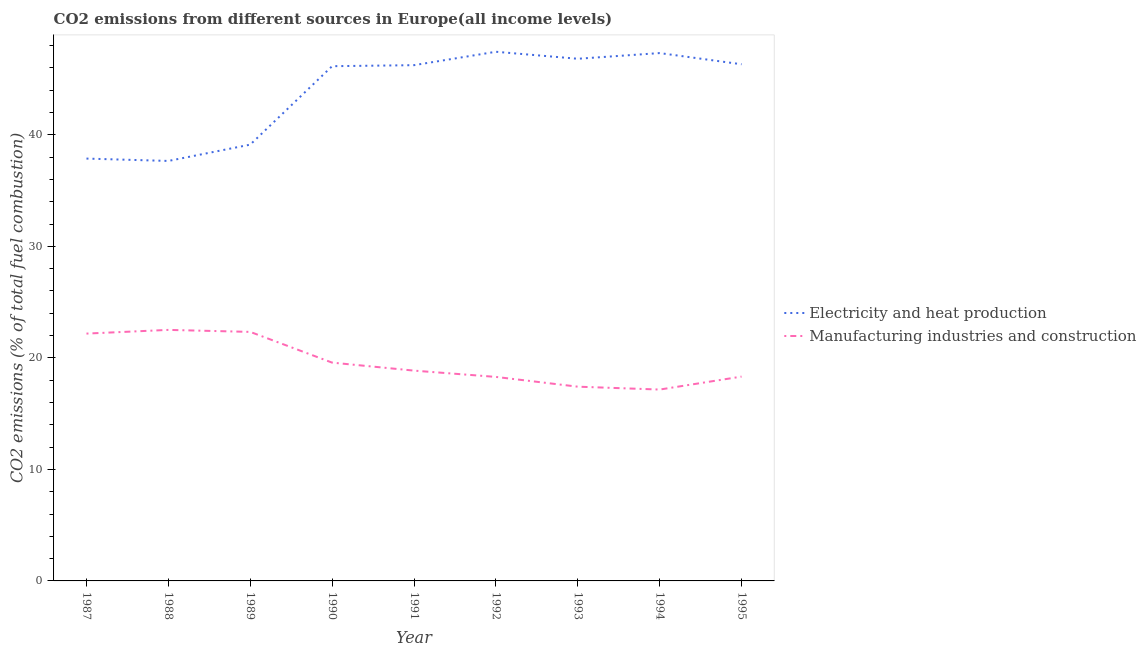How many different coloured lines are there?
Provide a short and direct response. 2. Does the line corresponding to co2 emissions due to electricity and heat production intersect with the line corresponding to co2 emissions due to manufacturing industries?
Your response must be concise. No. What is the co2 emissions due to electricity and heat production in 1992?
Your answer should be compact. 47.45. Across all years, what is the maximum co2 emissions due to manufacturing industries?
Offer a terse response. 22.51. Across all years, what is the minimum co2 emissions due to manufacturing industries?
Your response must be concise. 17.16. In which year was the co2 emissions due to manufacturing industries maximum?
Make the answer very short. 1988. What is the total co2 emissions due to electricity and heat production in the graph?
Provide a succinct answer. 394.98. What is the difference between the co2 emissions due to electricity and heat production in 1990 and that in 1994?
Your answer should be very brief. -1.18. What is the difference between the co2 emissions due to electricity and heat production in 1989 and the co2 emissions due to manufacturing industries in 1990?
Provide a succinct answer. 19.55. What is the average co2 emissions due to manufacturing industries per year?
Ensure brevity in your answer.  19.63. In the year 1992, what is the difference between the co2 emissions due to electricity and heat production and co2 emissions due to manufacturing industries?
Your answer should be compact. 29.15. What is the ratio of the co2 emissions due to manufacturing industries in 1988 to that in 1991?
Offer a terse response. 1.19. Is the co2 emissions due to electricity and heat production in 1988 less than that in 1995?
Your answer should be very brief. Yes. What is the difference between the highest and the second highest co2 emissions due to electricity and heat production?
Ensure brevity in your answer.  0.12. What is the difference between the highest and the lowest co2 emissions due to manufacturing industries?
Offer a very short reply. 5.35. In how many years, is the co2 emissions due to manufacturing industries greater than the average co2 emissions due to manufacturing industries taken over all years?
Offer a very short reply. 3. Is the sum of the co2 emissions due to manufacturing industries in 1988 and 1993 greater than the maximum co2 emissions due to electricity and heat production across all years?
Give a very brief answer. No. Is the co2 emissions due to manufacturing industries strictly less than the co2 emissions due to electricity and heat production over the years?
Offer a terse response. Yes. How many years are there in the graph?
Keep it short and to the point. 9. Are the values on the major ticks of Y-axis written in scientific E-notation?
Your answer should be compact. No. Does the graph contain any zero values?
Offer a very short reply. No. Does the graph contain grids?
Keep it short and to the point. No. Where does the legend appear in the graph?
Make the answer very short. Center right. How many legend labels are there?
Your response must be concise. 2. How are the legend labels stacked?
Make the answer very short. Vertical. What is the title of the graph?
Provide a succinct answer. CO2 emissions from different sources in Europe(all income levels). Does "Private funds" appear as one of the legend labels in the graph?
Make the answer very short. No. What is the label or title of the X-axis?
Ensure brevity in your answer.  Year. What is the label or title of the Y-axis?
Provide a succinct answer. CO2 emissions (% of total fuel combustion). What is the CO2 emissions (% of total fuel combustion) in Electricity and heat production in 1987?
Your answer should be compact. 37.87. What is the CO2 emissions (% of total fuel combustion) of Manufacturing industries and construction in 1987?
Give a very brief answer. 22.18. What is the CO2 emissions (% of total fuel combustion) in Electricity and heat production in 1988?
Give a very brief answer. 37.66. What is the CO2 emissions (% of total fuel combustion) in Manufacturing industries and construction in 1988?
Make the answer very short. 22.51. What is the CO2 emissions (% of total fuel combustion) of Electricity and heat production in 1989?
Provide a short and direct response. 39.12. What is the CO2 emissions (% of total fuel combustion) in Manufacturing industries and construction in 1989?
Offer a terse response. 22.33. What is the CO2 emissions (% of total fuel combustion) of Electricity and heat production in 1990?
Your answer should be very brief. 46.16. What is the CO2 emissions (% of total fuel combustion) of Manufacturing industries and construction in 1990?
Your response must be concise. 19.57. What is the CO2 emissions (% of total fuel combustion) in Electricity and heat production in 1991?
Your answer should be compact. 46.25. What is the CO2 emissions (% of total fuel combustion) in Manufacturing industries and construction in 1991?
Your response must be concise. 18.86. What is the CO2 emissions (% of total fuel combustion) in Electricity and heat production in 1992?
Give a very brief answer. 47.45. What is the CO2 emissions (% of total fuel combustion) in Manufacturing industries and construction in 1992?
Your answer should be compact. 18.29. What is the CO2 emissions (% of total fuel combustion) in Electricity and heat production in 1993?
Make the answer very short. 46.82. What is the CO2 emissions (% of total fuel combustion) in Manufacturing industries and construction in 1993?
Provide a short and direct response. 17.42. What is the CO2 emissions (% of total fuel combustion) in Electricity and heat production in 1994?
Your answer should be compact. 47.33. What is the CO2 emissions (% of total fuel combustion) in Manufacturing industries and construction in 1994?
Give a very brief answer. 17.16. What is the CO2 emissions (% of total fuel combustion) in Electricity and heat production in 1995?
Provide a succinct answer. 46.33. What is the CO2 emissions (% of total fuel combustion) in Manufacturing industries and construction in 1995?
Ensure brevity in your answer.  18.32. Across all years, what is the maximum CO2 emissions (% of total fuel combustion) in Electricity and heat production?
Your answer should be very brief. 47.45. Across all years, what is the maximum CO2 emissions (% of total fuel combustion) in Manufacturing industries and construction?
Your response must be concise. 22.51. Across all years, what is the minimum CO2 emissions (% of total fuel combustion) of Electricity and heat production?
Give a very brief answer. 37.66. Across all years, what is the minimum CO2 emissions (% of total fuel combustion) in Manufacturing industries and construction?
Your answer should be compact. 17.16. What is the total CO2 emissions (% of total fuel combustion) in Electricity and heat production in the graph?
Provide a short and direct response. 394.98. What is the total CO2 emissions (% of total fuel combustion) of Manufacturing industries and construction in the graph?
Your answer should be compact. 176.64. What is the difference between the CO2 emissions (% of total fuel combustion) of Electricity and heat production in 1987 and that in 1988?
Provide a short and direct response. 0.21. What is the difference between the CO2 emissions (% of total fuel combustion) in Manufacturing industries and construction in 1987 and that in 1988?
Offer a very short reply. -0.33. What is the difference between the CO2 emissions (% of total fuel combustion) of Electricity and heat production in 1987 and that in 1989?
Your response must be concise. -1.25. What is the difference between the CO2 emissions (% of total fuel combustion) in Manufacturing industries and construction in 1987 and that in 1989?
Offer a very short reply. -0.15. What is the difference between the CO2 emissions (% of total fuel combustion) in Electricity and heat production in 1987 and that in 1990?
Keep it short and to the point. -8.28. What is the difference between the CO2 emissions (% of total fuel combustion) in Manufacturing industries and construction in 1987 and that in 1990?
Ensure brevity in your answer.  2.6. What is the difference between the CO2 emissions (% of total fuel combustion) in Electricity and heat production in 1987 and that in 1991?
Offer a terse response. -8.38. What is the difference between the CO2 emissions (% of total fuel combustion) in Manufacturing industries and construction in 1987 and that in 1991?
Your answer should be very brief. 3.32. What is the difference between the CO2 emissions (% of total fuel combustion) in Electricity and heat production in 1987 and that in 1992?
Offer a terse response. -9.58. What is the difference between the CO2 emissions (% of total fuel combustion) in Manufacturing industries and construction in 1987 and that in 1992?
Make the answer very short. 3.88. What is the difference between the CO2 emissions (% of total fuel combustion) of Electricity and heat production in 1987 and that in 1993?
Your answer should be very brief. -8.95. What is the difference between the CO2 emissions (% of total fuel combustion) in Manufacturing industries and construction in 1987 and that in 1993?
Your answer should be compact. 4.76. What is the difference between the CO2 emissions (% of total fuel combustion) in Electricity and heat production in 1987 and that in 1994?
Your answer should be very brief. -9.46. What is the difference between the CO2 emissions (% of total fuel combustion) in Manufacturing industries and construction in 1987 and that in 1994?
Your response must be concise. 5.02. What is the difference between the CO2 emissions (% of total fuel combustion) in Electricity and heat production in 1987 and that in 1995?
Make the answer very short. -8.46. What is the difference between the CO2 emissions (% of total fuel combustion) in Manufacturing industries and construction in 1987 and that in 1995?
Provide a succinct answer. 3.86. What is the difference between the CO2 emissions (% of total fuel combustion) in Electricity and heat production in 1988 and that in 1989?
Offer a terse response. -1.46. What is the difference between the CO2 emissions (% of total fuel combustion) in Manufacturing industries and construction in 1988 and that in 1989?
Make the answer very short. 0.18. What is the difference between the CO2 emissions (% of total fuel combustion) of Electricity and heat production in 1988 and that in 1990?
Your response must be concise. -8.5. What is the difference between the CO2 emissions (% of total fuel combustion) in Manufacturing industries and construction in 1988 and that in 1990?
Provide a short and direct response. 2.93. What is the difference between the CO2 emissions (% of total fuel combustion) of Electricity and heat production in 1988 and that in 1991?
Your answer should be very brief. -8.59. What is the difference between the CO2 emissions (% of total fuel combustion) in Manufacturing industries and construction in 1988 and that in 1991?
Give a very brief answer. 3.65. What is the difference between the CO2 emissions (% of total fuel combustion) of Electricity and heat production in 1988 and that in 1992?
Make the answer very short. -9.79. What is the difference between the CO2 emissions (% of total fuel combustion) in Manufacturing industries and construction in 1988 and that in 1992?
Provide a short and direct response. 4.22. What is the difference between the CO2 emissions (% of total fuel combustion) of Electricity and heat production in 1988 and that in 1993?
Provide a succinct answer. -9.16. What is the difference between the CO2 emissions (% of total fuel combustion) of Manufacturing industries and construction in 1988 and that in 1993?
Provide a short and direct response. 5.09. What is the difference between the CO2 emissions (% of total fuel combustion) of Electricity and heat production in 1988 and that in 1994?
Make the answer very short. -9.67. What is the difference between the CO2 emissions (% of total fuel combustion) in Manufacturing industries and construction in 1988 and that in 1994?
Your response must be concise. 5.35. What is the difference between the CO2 emissions (% of total fuel combustion) of Electricity and heat production in 1988 and that in 1995?
Ensure brevity in your answer.  -8.67. What is the difference between the CO2 emissions (% of total fuel combustion) in Manufacturing industries and construction in 1988 and that in 1995?
Your answer should be compact. 4.19. What is the difference between the CO2 emissions (% of total fuel combustion) in Electricity and heat production in 1989 and that in 1990?
Give a very brief answer. -7.03. What is the difference between the CO2 emissions (% of total fuel combustion) of Manufacturing industries and construction in 1989 and that in 1990?
Your answer should be very brief. 2.76. What is the difference between the CO2 emissions (% of total fuel combustion) of Electricity and heat production in 1989 and that in 1991?
Your response must be concise. -7.13. What is the difference between the CO2 emissions (% of total fuel combustion) of Manufacturing industries and construction in 1989 and that in 1991?
Make the answer very short. 3.47. What is the difference between the CO2 emissions (% of total fuel combustion) of Electricity and heat production in 1989 and that in 1992?
Give a very brief answer. -8.33. What is the difference between the CO2 emissions (% of total fuel combustion) in Manufacturing industries and construction in 1989 and that in 1992?
Give a very brief answer. 4.04. What is the difference between the CO2 emissions (% of total fuel combustion) of Electricity and heat production in 1989 and that in 1993?
Ensure brevity in your answer.  -7.7. What is the difference between the CO2 emissions (% of total fuel combustion) of Manufacturing industries and construction in 1989 and that in 1993?
Ensure brevity in your answer.  4.91. What is the difference between the CO2 emissions (% of total fuel combustion) in Electricity and heat production in 1989 and that in 1994?
Your answer should be very brief. -8.21. What is the difference between the CO2 emissions (% of total fuel combustion) in Manufacturing industries and construction in 1989 and that in 1994?
Your response must be concise. 5.17. What is the difference between the CO2 emissions (% of total fuel combustion) in Electricity and heat production in 1989 and that in 1995?
Give a very brief answer. -7.21. What is the difference between the CO2 emissions (% of total fuel combustion) in Manufacturing industries and construction in 1989 and that in 1995?
Your answer should be compact. 4.01. What is the difference between the CO2 emissions (% of total fuel combustion) in Electricity and heat production in 1990 and that in 1991?
Keep it short and to the point. -0.09. What is the difference between the CO2 emissions (% of total fuel combustion) of Manufacturing industries and construction in 1990 and that in 1991?
Offer a terse response. 0.72. What is the difference between the CO2 emissions (% of total fuel combustion) in Electricity and heat production in 1990 and that in 1992?
Provide a succinct answer. -1.29. What is the difference between the CO2 emissions (% of total fuel combustion) of Manufacturing industries and construction in 1990 and that in 1992?
Keep it short and to the point. 1.28. What is the difference between the CO2 emissions (% of total fuel combustion) of Electricity and heat production in 1990 and that in 1993?
Keep it short and to the point. -0.67. What is the difference between the CO2 emissions (% of total fuel combustion) in Manufacturing industries and construction in 1990 and that in 1993?
Keep it short and to the point. 2.16. What is the difference between the CO2 emissions (% of total fuel combustion) of Electricity and heat production in 1990 and that in 1994?
Your answer should be very brief. -1.18. What is the difference between the CO2 emissions (% of total fuel combustion) in Manufacturing industries and construction in 1990 and that in 1994?
Your response must be concise. 2.42. What is the difference between the CO2 emissions (% of total fuel combustion) of Electricity and heat production in 1990 and that in 1995?
Provide a succinct answer. -0.17. What is the difference between the CO2 emissions (% of total fuel combustion) of Manufacturing industries and construction in 1990 and that in 1995?
Give a very brief answer. 1.25. What is the difference between the CO2 emissions (% of total fuel combustion) in Electricity and heat production in 1991 and that in 1992?
Your answer should be very brief. -1.2. What is the difference between the CO2 emissions (% of total fuel combustion) of Manufacturing industries and construction in 1991 and that in 1992?
Provide a short and direct response. 0.56. What is the difference between the CO2 emissions (% of total fuel combustion) of Electricity and heat production in 1991 and that in 1993?
Keep it short and to the point. -0.57. What is the difference between the CO2 emissions (% of total fuel combustion) of Manufacturing industries and construction in 1991 and that in 1993?
Keep it short and to the point. 1.44. What is the difference between the CO2 emissions (% of total fuel combustion) in Electricity and heat production in 1991 and that in 1994?
Keep it short and to the point. -1.08. What is the difference between the CO2 emissions (% of total fuel combustion) in Manufacturing industries and construction in 1991 and that in 1994?
Your answer should be very brief. 1.7. What is the difference between the CO2 emissions (% of total fuel combustion) of Electricity and heat production in 1991 and that in 1995?
Keep it short and to the point. -0.08. What is the difference between the CO2 emissions (% of total fuel combustion) in Manufacturing industries and construction in 1991 and that in 1995?
Ensure brevity in your answer.  0.54. What is the difference between the CO2 emissions (% of total fuel combustion) in Electricity and heat production in 1992 and that in 1993?
Give a very brief answer. 0.63. What is the difference between the CO2 emissions (% of total fuel combustion) of Manufacturing industries and construction in 1992 and that in 1993?
Offer a terse response. 0.88. What is the difference between the CO2 emissions (% of total fuel combustion) of Electricity and heat production in 1992 and that in 1994?
Offer a terse response. 0.12. What is the difference between the CO2 emissions (% of total fuel combustion) in Manufacturing industries and construction in 1992 and that in 1994?
Your answer should be very brief. 1.13. What is the difference between the CO2 emissions (% of total fuel combustion) of Electricity and heat production in 1992 and that in 1995?
Offer a terse response. 1.12. What is the difference between the CO2 emissions (% of total fuel combustion) in Manufacturing industries and construction in 1992 and that in 1995?
Ensure brevity in your answer.  -0.03. What is the difference between the CO2 emissions (% of total fuel combustion) of Electricity and heat production in 1993 and that in 1994?
Ensure brevity in your answer.  -0.51. What is the difference between the CO2 emissions (% of total fuel combustion) in Manufacturing industries and construction in 1993 and that in 1994?
Keep it short and to the point. 0.26. What is the difference between the CO2 emissions (% of total fuel combustion) of Electricity and heat production in 1993 and that in 1995?
Your answer should be very brief. 0.49. What is the difference between the CO2 emissions (% of total fuel combustion) in Manufacturing industries and construction in 1993 and that in 1995?
Your answer should be compact. -0.9. What is the difference between the CO2 emissions (% of total fuel combustion) of Electricity and heat production in 1994 and that in 1995?
Ensure brevity in your answer.  1. What is the difference between the CO2 emissions (% of total fuel combustion) of Manufacturing industries and construction in 1994 and that in 1995?
Your answer should be very brief. -1.16. What is the difference between the CO2 emissions (% of total fuel combustion) in Electricity and heat production in 1987 and the CO2 emissions (% of total fuel combustion) in Manufacturing industries and construction in 1988?
Your answer should be very brief. 15.36. What is the difference between the CO2 emissions (% of total fuel combustion) of Electricity and heat production in 1987 and the CO2 emissions (% of total fuel combustion) of Manufacturing industries and construction in 1989?
Offer a terse response. 15.54. What is the difference between the CO2 emissions (% of total fuel combustion) in Electricity and heat production in 1987 and the CO2 emissions (% of total fuel combustion) in Manufacturing industries and construction in 1990?
Provide a short and direct response. 18.3. What is the difference between the CO2 emissions (% of total fuel combustion) in Electricity and heat production in 1987 and the CO2 emissions (% of total fuel combustion) in Manufacturing industries and construction in 1991?
Your response must be concise. 19.01. What is the difference between the CO2 emissions (% of total fuel combustion) in Electricity and heat production in 1987 and the CO2 emissions (% of total fuel combustion) in Manufacturing industries and construction in 1992?
Provide a short and direct response. 19.58. What is the difference between the CO2 emissions (% of total fuel combustion) of Electricity and heat production in 1987 and the CO2 emissions (% of total fuel combustion) of Manufacturing industries and construction in 1993?
Your response must be concise. 20.45. What is the difference between the CO2 emissions (% of total fuel combustion) of Electricity and heat production in 1987 and the CO2 emissions (% of total fuel combustion) of Manufacturing industries and construction in 1994?
Offer a terse response. 20.71. What is the difference between the CO2 emissions (% of total fuel combustion) of Electricity and heat production in 1987 and the CO2 emissions (% of total fuel combustion) of Manufacturing industries and construction in 1995?
Provide a short and direct response. 19.55. What is the difference between the CO2 emissions (% of total fuel combustion) in Electricity and heat production in 1988 and the CO2 emissions (% of total fuel combustion) in Manufacturing industries and construction in 1989?
Ensure brevity in your answer.  15.33. What is the difference between the CO2 emissions (% of total fuel combustion) of Electricity and heat production in 1988 and the CO2 emissions (% of total fuel combustion) of Manufacturing industries and construction in 1990?
Your answer should be very brief. 18.08. What is the difference between the CO2 emissions (% of total fuel combustion) in Electricity and heat production in 1988 and the CO2 emissions (% of total fuel combustion) in Manufacturing industries and construction in 1991?
Provide a succinct answer. 18.8. What is the difference between the CO2 emissions (% of total fuel combustion) of Electricity and heat production in 1988 and the CO2 emissions (% of total fuel combustion) of Manufacturing industries and construction in 1992?
Ensure brevity in your answer.  19.37. What is the difference between the CO2 emissions (% of total fuel combustion) in Electricity and heat production in 1988 and the CO2 emissions (% of total fuel combustion) in Manufacturing industries and construction in 1993?
Provide a succinct answer. 20.24. What is the difference between the CO2 emissions (% of total fuel combustion) in Electricity and heat production in 1988 and the CO2 emissions (% of total fuel combustion) in Manufacturing industries and construction in 1994?
Your response must be concise. 20.5. What is the difference between the CO2 emissions (% of total fuel combustion) of Electricity and heat production in 1988 and the CO2 emissions (% of total fuel combustion) of Manufacturing industries and construction in 1995?
Provide a short and direct response. 19.34. What is the difference between the CO2 emissions (% of total fuel combustion) of Electricity and heat production in 1989 and the CO2 emissions (% of total fuel combustion) of Manufacturing industries and construction in 1990?
Your answer should be very brief. 19.55. What is the difference between the CO2 emissions (% of total fuel combustion) of Electricity and heat production in 1989 and the CO2 emissions (% of total fuel combustion) of Manufacturing industries and construction in 1991?
Your answer should be compact. 20.26. What is the difference between the CO2 emissions (% of total fuel combustion) of Electricity and heat production in 1989 and the CO2 emissions (% of total fuel combustion) of Manufacturing industries and construction in 1992?
Your answer should be very brief. 20.83. What is the difference between the CO2 emissions (% of total fuel combustion) in Electricity and heat production in 1989 and the CO2 emissions (% of total fuel combustion) in Manufacturing industries and construction in 1993?
Keep it short and to the point. 21.7. What is the difference between the CO2 emissions (% of total fuel combustion) of Electricity and heat production in 1989 and the CO2 emissions (% of total fuel combustion) of Manufacturing industries and construction in 1994?
Your answer should be compact. 21.96. What is the difference between the CO2 emissions (% of total fuel combustion) in Electricity and heat production in 1989 and the CO2 emissions (% of total fuel combustion) in Manufacturing industries and construction in 1995?
Your response must be concise. 20.8. What is the difference between the CO2 emissions (% of total fuel combustion) in Electricity and heat production in 1990 and the CO2 emissions (% of total fuel combustion) in Manufacturing industries and construction in 1991?
Make the answer very short. 27.3. What is the difference between the CO2 emissions (% of total fuel combustion) in Electricity and heat production in 1990 and the CO2 emissions (% of total fuel combustion) in Manufacturing industries and construction in 1992?
Keep it short and to the point. 27.86. What is the difference between the CO2 emissions (% of total fuel combustion) in Electricity and heat production in 1990 and the CO2 emissions (% of total fuel combustion) in Manufacturing industries and construction in 1993?
Make the answer very short. 28.74. What is the difference between the CO2 emissions (% of total fuel combustion) in Electricity and heat production in 1990 and the CO2 emissions (% of total fuel combustion) in Manufacturing industries and construction in 1994?
Your response must be concise. 29. What is the difference between the CO2 emissions (% of total fuel combustion) in Electricity and heat production in 1990 and the CO2 emissions (% of total fuel combustion) in Manufacturing industries and construction in 1995?
Provide a short and direct response. 27.83. What is the difference between the CO2 emissions (% of total fuel combustion) of Electricity and heat production in 1991 and the CO2 emissions (% of total fuel combustion) of Manufacturing industries and construction in 1992?
Offer a terse response. 27.95. What is the difference between the CO2 emissions (% of total fuel combustion) of Electricity and heat production in 1991 and the CO2 emissions (% of total fuel combustion) of Manufacturing industries and construction in 1993?
Your answer should be compact. 28.83. What is the difference between the CO2 emissions (% of total fuel combustion) of Electricity and heat production in 1991 and the CO2 emissions (% of total fuel combustion) of Manufacturing industries and construction in 1994?
Provide a succinct answer. 29.09. What is the difference between the CO2 emissions (% of total fuel combustion) in Electricity and heat production in 1991 and the CO2 emissions (% of total fuel combustion) in Manufacturing industries and construction in 1995?
Keep it short and to the point. 27.93. What is the difference between the CO2 emissions (% of total fuel combustion) in Electricity and heat production in 1992 and the CO2 emissions (% of total fuel combustion) in Manufacturing industries and construction in 1993?
Provide a succinct answer. 30.03. What is the difference between the CO2 emissions (% of total fuel combustion) in Electricity and heat production in 1992 and the CO2 emissions (% of total fuel combustion) in Manufacturing industries and construction in 1994?
Your response must be concise. 30.29. What is the difference between the CO2 emissions (% of total fuel combustion) in Electricity and heat production in 1992 and the CO2 emissions (% of total fuel combustion) in Manufacturing industries and construction in 1995?
Provide a succinct answer. 29.13. What is the difference between the CO2 emissions (% of total fuel combustion) of Electricity and heat production in 1993 and the CO2 emissions (% of total fuel combustion) of Manufacturing industries and construction in 1994?
Ensure brevity in your answer.  29.66. What is the difference between the CO2 emissions (% of total fuel combustion) of Electricity and heat production in 1993 and the CO2 emissions (% of total fuel combustion) of Manufacturing industries and construction in 1995?
Give a very brief answer. 28.5. What is the difference between the CO2 emissions (% of total fuel combustion) of Electricity and heat production in 1994 and the CO2 emissions (% of total fuel combustion) of Manufacturing industries and construction in 1995?
Offer a terse response. 29.01. What is the average CO2 emissions (% of total fuel combustion) of Electricity and heat production per year?
Your answer should be very brief. 43.89. What is the average CO2 emissions (% of total fuel combustion) of Manufacturing industries and construction per year?
Ensure brevity in your answer.  19.63. In the year 1987, what is the difference between the CO2 emissions (% of total fuel combustion) in Electricity and heat production and CO2 emissions (% of total fuel combustion) in Manufacturing industries and construction?
Your answer should be very brief. 15.69. In the year 1988, what is the difference between the CO2 emissions (% of total fuel combustion) in Electricity and heat production and CO2 emissions (% of total fuel combustion) in Manufacturing industries and construction?
Provide a succinct answer. 15.15. In the year 1989, what is the difference between the CO2 emissions (% of total fuel combustion) of Electricity and heat production and CO2 emissions (% of total fuel combustion) of Manufacturing industries and construction?
Provide a short and direct response. 16.79. In the year 1990, what is the difference between the CO2 emissions (% of total fuel combustion) of Electricity and heat production and CO2 emissions (% of total fuel combustion) of Manufacturing industries and construction?
Offer a very short reply. 26.58. In the year 1991, what is the difference between the CO2 emissions (% of total fuel combustion) of Electricity and heat production and CO2 emissions (% of total fuel combustion) of Manufacturing industries and construction?
Offer a terse response. 27.39. In the year 1992, what is the difference between the CO2 emissions (% of total fuel combustion) in Electricity and heat production and CO2 emissions (% of total fuel combustion) in Manufacturing industries and construction?
Ensure brevity in your answer.  29.15. In the year 1993, what is the difference between the CO2 emissions (% of total fuel combustion) in Electricity and heat production and CO2 emissions (% of total fuel combustion) in Manufacturing industries and construction?
Provide a succinct answer. 29.4. In the year 1994, what is the difference between the CO2 emissions (% of total fuel combustion) of Electricity and heat production and CO2 emissions (% of total fuel combustion) of Manufacturing industries and construction?
Provide a succinct answer. 30.17. In the year 1995, what is the difference between the CO2 emissions (% of total fuel combustion) of Electricity and heat production and CO2 emissions (% of total fuel combustion) of Manufacturing industries and construction?
Give a very brief answer. 28.01. What is the ratio of the CO2 emissions (% of total fuel combustion) in Electricity and heat production in 1987 to that in 1988?
Your answer should be very brief. 1.01. What is the ratio of the CO2 emissions (% of total fuel combustion) in Manufacturing industries and construction in 1987 to that in 1988?
Your answer should be compact. 0.99. What is the ratio of the CO2 emissions (% of total fuel combustion) in Electricity and heat production in 1987 to that in 1990?
Offer a very short reply. 0.82. What is the ratio of the CO2 emissions (% of total fuel combustion) in Manufacturing industries and construction in 1987 to that in 1990?
Make the answer very short. 1.13. What is the ratio of the CO2 emissions (% of total fuel combustion) of Electricity and heat production in 1987 to that in 1991?
Offer a terse response. 0.82. What is the ratio of the CO2 emissions (% of total fuel combustion) of Manufacturing industries and construction in 1987 to that in 1991?
Give a very brief answer. 1.18. What is the ratio of the CO2 emissions (% of total fuel combustion) of Electricity and heat production in 1987 to that in 1992?
Provide a succinct answer. 0.8. What is the ratio of the CO2 emissions (% of total fuel combustion) in Manufacturing industries and construction in 1987 to that in 1992?
Offer a very short reply. 1.21. What is the ratio of the CO2 emissions (% of total fuel combustion) in Electricity and heat production in 1987 to that in 1993?
Give a very brief answer. 0.81. What is the ratio of the CO2 emissions (% of total fuel combustion) in Manufacturing industries and construction in 1987 to that in 1993?
Your answer should be compact. 1.27. What is the ratio of the CO2 emissions (% of total fuel combustion) of Electricity and heat production in 1987 to that in 1994?
Ensure brevity in your answer.  0.8. What is the ratio of the CO2 emissions (% of total fuel combustion) of Manufacturing industries and construction in 1987 to that in 1994?
Offer a terse response. 1.29. What is the ratio of the CO2 emissions (% of total fuel combustion) of Electricity and heat production in 1987 to that in 1995?
Give a very brief answer. 0.82. What is the ratio of the CO2 emissions (% of total fuel combustion) in Manufacturing industries and construction in 1987 to that in 1995?
Offer a terse response. 1.21. What is the ratio of the CO2 emissions (% of total fuel combustion) of Electricity and heat production in 1988 to that in 1989?
Make the answer very short. 0.96. What is the ratio of the CO2 emissions (% of total fuel combustion) in Manufacturing industries and construction in 1988 to that in 1989?
Your answer should be very brief. 1.01. What is the ratio of the CO2 emissions (% of total fuel combustion) in Electricity and heat production in 1988 to that in 1990?
Offer a very short reply. 0.82. What is the ratio of the CO2 emissions (% of total fuel combustion) in Manufacturing industries and construction in 1988 to that in 1990?
Your answer should be very brief. 1.15. What is the ratio of the CO2 emissions (% of total fuel combustion) of Electricity and heat production in 1988 to that in 1991?
Keep it short and to the point. 0.81. What is the ratio of the CO2 emissions (% of total fuel combustion) in Manufacturing industries and construction in 1988 to that in 1991?
Your response must be concise. 1.19. What is the ratio of the CO2 emissions (% of total fuel combustion) of Electricity and heat production in 1988 to that in 1992?
Keep it short and to the point. 0.79. What is the ratio of the CO2 emissions (% of total fuel combustion) in Manufacturing industries and construction in 1988 to that in 1992?
Give a very brief answer. 1.23. What is the ratio of the CO2 emissions (% of total fuel combustion) of Electricity and heat production in 1988 to that in 1993?
Your answer should be compact. 0.8. What is the ratio of the CO2 emissions (% of total fuel combustion) in Manufacturing industries and construction in 1988 to that in 1993?
Offer a very short reply. 1.29. What is the ratio of the CO2 emissions (% of total fuel combustion) of Electricity and heat production in 1988 to that in 1994?
Ensure brevity in your answer.  0.8. What is the ratio of the CO2 emissions (% of total fuel combustion) in Manufacturing industries and construction in 1988 to that in 1994?
Offer a very short reply. 1.31. What is the ratio of the CO2 emissions (% of total fuel combustion) in Electricity and heat production in 1988 to that in 1995?
Give a very brief answer. 0.81. What is the ratio of the CO2 emissions (% of total fuel combustion) of Manufacturing industries and construction in 1988 to that in 1995?
Offer a very short reply. 1.23. What is the ratio of the CO2 emissions (% of total fuel combustion) of Electricity and heat production in 1989 to that in 1990?
Your answer should be compact. 0.85. What is the ratio of the CO2 emissions (% of total fuel combustion) of Manufacturing industries and construction in 1989 to that in 1990?
Make the answer very short. 1.14. What is the ratio of the CO2 emissions (% of total fuel combustion) of Electricity and heat production in 1989 to that in 1991?
Ensure brevity in your answer.  0.85. What is the ratio of the CO2 emissions (% of total fuel combustion) of Manufacturing industries and construction in 1989 to that in 1991?
Provide a short and direct response. 1.18. What is the ratio of the CO2 emissions (% of total fuel combustion) of Electricity and heat production in 1989 to that in 1992?
Keep it short and to the point. 0.82. What is the ratio of the CO2 emissions (% of total fuel combustion) of Manufacturing industries and construction in 1989 to that in 1992?
Offer a very short reply. 1.22. What is the ratio of the CO2 emissions (% of total fuel combustion) in Electricity and heat production in 1989 to that in 1993?
Ensure brevity in your answer.  0.84. What is the ratio of the CO2 emissions (% of total fuel combustion) in Manufacturing industries and construction in 1989 to that in 1993?
Provide a succinct answer. 1.28. What is the ratio of the CO2 emissions (% of total fuel combustion) in Electricity and heat production in 1989 to that in 1994?
Your answer should be compact. 0.83. What is the ratio of the CO2 emissions (% of total fuel combustion) of Manufacturing industries and construction in 1989 to that in 1994?
Offer a terse response. 1.3. What is the ratio of the CO2 emissions (% of total fuel combustion) in Electricity and heat production in 1989 to that in 1995?
Give a very brief answer. 0.84. What is the ratio of the CO2 emissions (% of total fuel combustion) in Manufacturing industries and construction in 1989 to that in 1995?
Offer a very short reply. 1.22. What is the ratio of the CO2 emissions (% of total fuel combustion) of Manufacturing industries and construction in 1990 to that in 1991?
Provide a short and direct response. 1.04. What is the ratio of the CO2 emissions (% of total fuel combustion) in Electricity and heat production in 1990 to that in 1992?
Your answer should be very brief. 0.97. What is the ratio of the CO2 emissions (% of total fuel combustion) of Manufacturing industries and construction in 1990 to that in 1992?
Ensure brevity in your answer.  1.07. What is the ratio of the CO2 emissions (% of total fuel combustion) of Electricity and heat production in 1990 to that in 1993?
Provide a succinct answer. 0.99. What is the ratio of the CO2 emissions (% of total fuel combustion) of Manufacturing industries and construction in 1990 to that in 1993?
Give a very brief answer. 1.12. What is the ratio of the CO2 emissions (% of total fuel combustion) in Electricity and heat production in 1990 to that in 1994?
Offer a very short reply. 0.98. What is the ratio of the CO2 emissions (% of total fuel combustion) in Manufacturing industries and construction in 1990 to that in 1994?
Your response must be concise. 1.14. What is the ratio of the CO2 emissions (% of total fuel combustion) of Electricity and heat production in 1990 to that in 1995?
Your answer should be compact. 1. What is the ratio of the CO2 emissions (% of total fuel combustion) in Manufacturing industries and construction in 1990 to that in 1995?
Your answer should be very brief. 1.07. What is the ratio of the CO2 emissions (% of total fuel combustion) of Electricity and heat production in 1991 to that in 1992?
Give a very brief answer. 0.97. What is the ratio of the CO2 emissions (% of total fuel combustion) in Manufacturing industries and construction in 1991 to that in 1992?
Offer a very short reply. 1.03. What is the ratio of the CO2 emissions (% of total fuel combustion) in Manufacturing industries and construction in 1991 to that in 1993?
Your response must be concise. 1.08. What is the ratio of the CO2 emissions (% of total fuel combustion) of Electricity and heat production in 1991 to that in 1994?
Provide a short and direct response. 0.98. What is the ratio of the CO2 emissions (% of total fuel combustion) of Manufacturing industries and construction in 1991 to that in 1994?
Provide a succinct answer. 1.1. What is the ratio of the CO2 emissions (% of total fuel combustion) in Manufacturing industries and construction in 1991 to that in 1995?
Keep it short and to the point. 1.03. What is the ratio of the CO2 emissions (% of total fuel combustion) of Electricity and heat production in 1992 to that in 1993?
Provide a short and direct response. 1.01. What is the ratio of the CO2 emissions (% of total fuel combustion) in Manufacturing industries and construction in 1992 to that in 1993?
Offer a very short reply. 1.05. What is the ratio of the CO2 emissions (% of total fuel combustion) in Manufacturing industries and construction in 1992 to that in 1994?
Give a very brief answer. 1.07. What is the ratio of the CO2 emissions (% of total fuel combustion) of Electricity and heat production in 1992 to that in 1995?
Offer a terse response. 1.02. What is the ratio of the CO2 emissions (% of total fuel combustion) of Electricity and heat production in 1993 to that in 1994?
Your answer should be very brief. 0.99. What is the ratio of the CO2 emissions (% of total fuel combustion) in Manufacturing industries and construction in 1993 to that in 1994?
Make the answer very short. 1.02. What is the ratio of the CO2 emissions (% of total fuel combustion) of Electricity and heat production in 1993 to that in 1995?
Provide a succinct answer. 1.01. What is the ratio of the CO2 emissions (% of total fuel combustion) of Manufacturing industries and construction in 1993 to that in 1995?
Ensure brevity in your answer.  0.95. What is the ratio of the CO2 emissions (% of total fuel combustion) in Electricity and heat production in 1994 to that in 1995?
Make the answer very short. 1.02. What is the ratio of the CO2 emissions (% of total fuel combustion) of Manufacturing industries and construction in 1994 to that in 1995?
Make the answer very short. 0.94. What is the difference between the highest and the second highest CO2 emissions (% of total fuel combustion) of Electricity and heat production?
Make the answer very short. 0.12. What is the difference between the highest and the second highest CO2 emissions (% of total fuel combustion) in Manufacturing industries and construction?
Your answer should be very brief. 0.18. What is the difference between the highest and the lowest CO2 emissions (% of total fuel combustion) of Electricity and heat production?
Provide a short and direct response. 9.79. What is the difference between the highest and the lowest CO2 emissions (% of total fuel combustion) of Manufacturing industries and construction?
Provide a succinct answer. 5.35. 